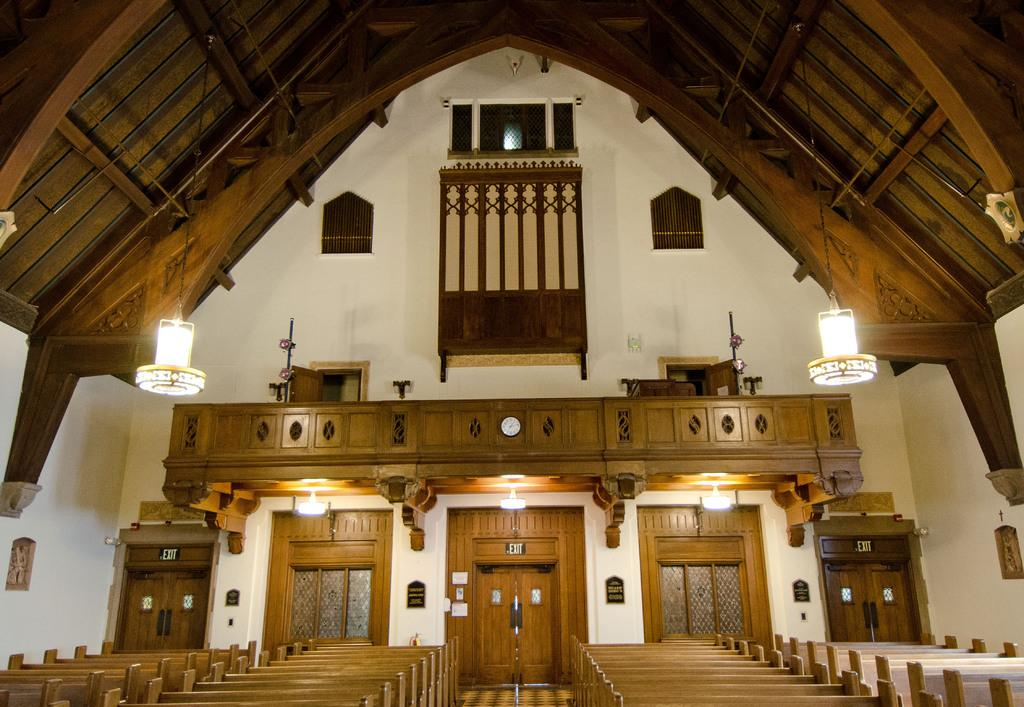Where is the location of the image? The image is inside a building, specifically on a rooftop. What architectural features can be seen in the image? There are windows, doors, and benches visible in the image. What time-related object is present in the image? There is a clock in the image. What type of signage is present in the image? There are sign boards in the image, and they are located on the wall. What type of lighting is present in the image? There are lights in the image. What type of drink is being served on the benches in the image? A: There is no drink present in the image; the benches are simply furniture for seating. What is the tendency of the sign boards to guide people in the image? The provided facts do not mention any guidance or direction provided by the sign boards; they are simply signage on the wall. 